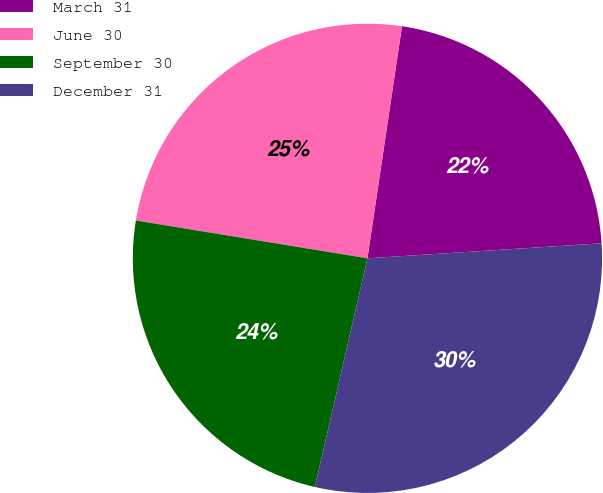Convert chart. <chart><loc_0><loc_0><loc_500><loc_500><pie_chart><fcel>March 31<fcel>June 30<fcel>September 30<fcel>December 31<nl><fcel>21.63%<fcel>24.78%<fcel>23.98%<fcel>29.62%<nl></chart> 